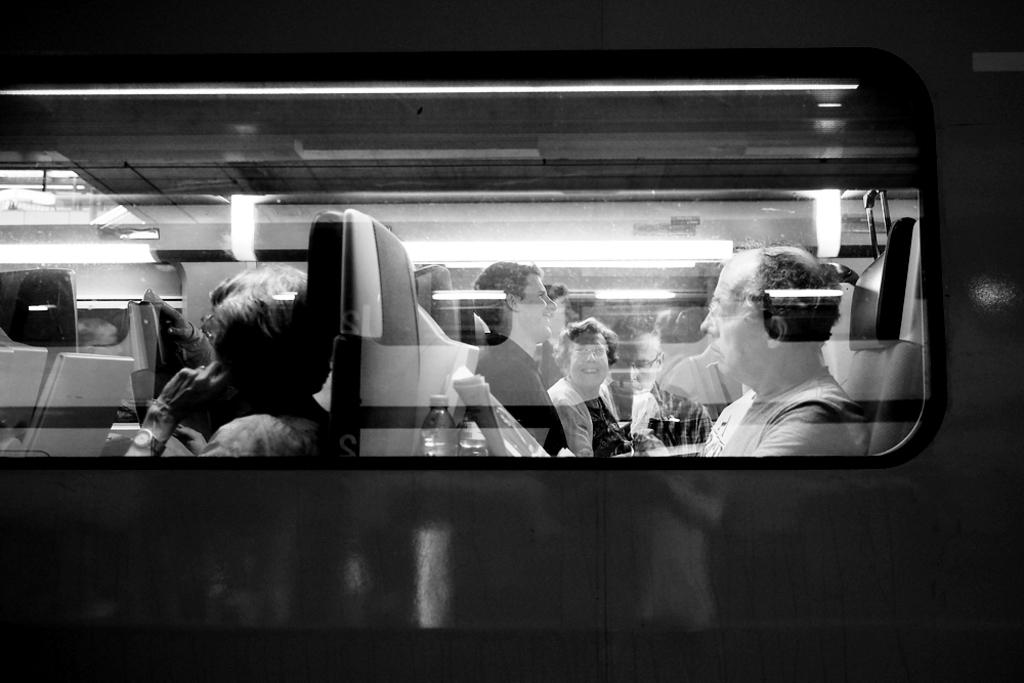What is the color scheme of the image? The image is black and white. What type of vehicle is visible in the image? There is a vehicle with a glass window in the image. What can be seen inside the vehicle? There are people sitting on the seats in the vehicle. What type of government is depicted in the image? There is no depiction of a government in the image; it features a black and white vehicle with people sitting inside. 